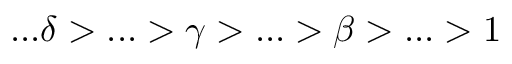<formula> <loc_0><loc_0><loc_500><loc_500>\dots \delta > \dots > \gamma > \dots > \beta > \dots > 1</formula> 